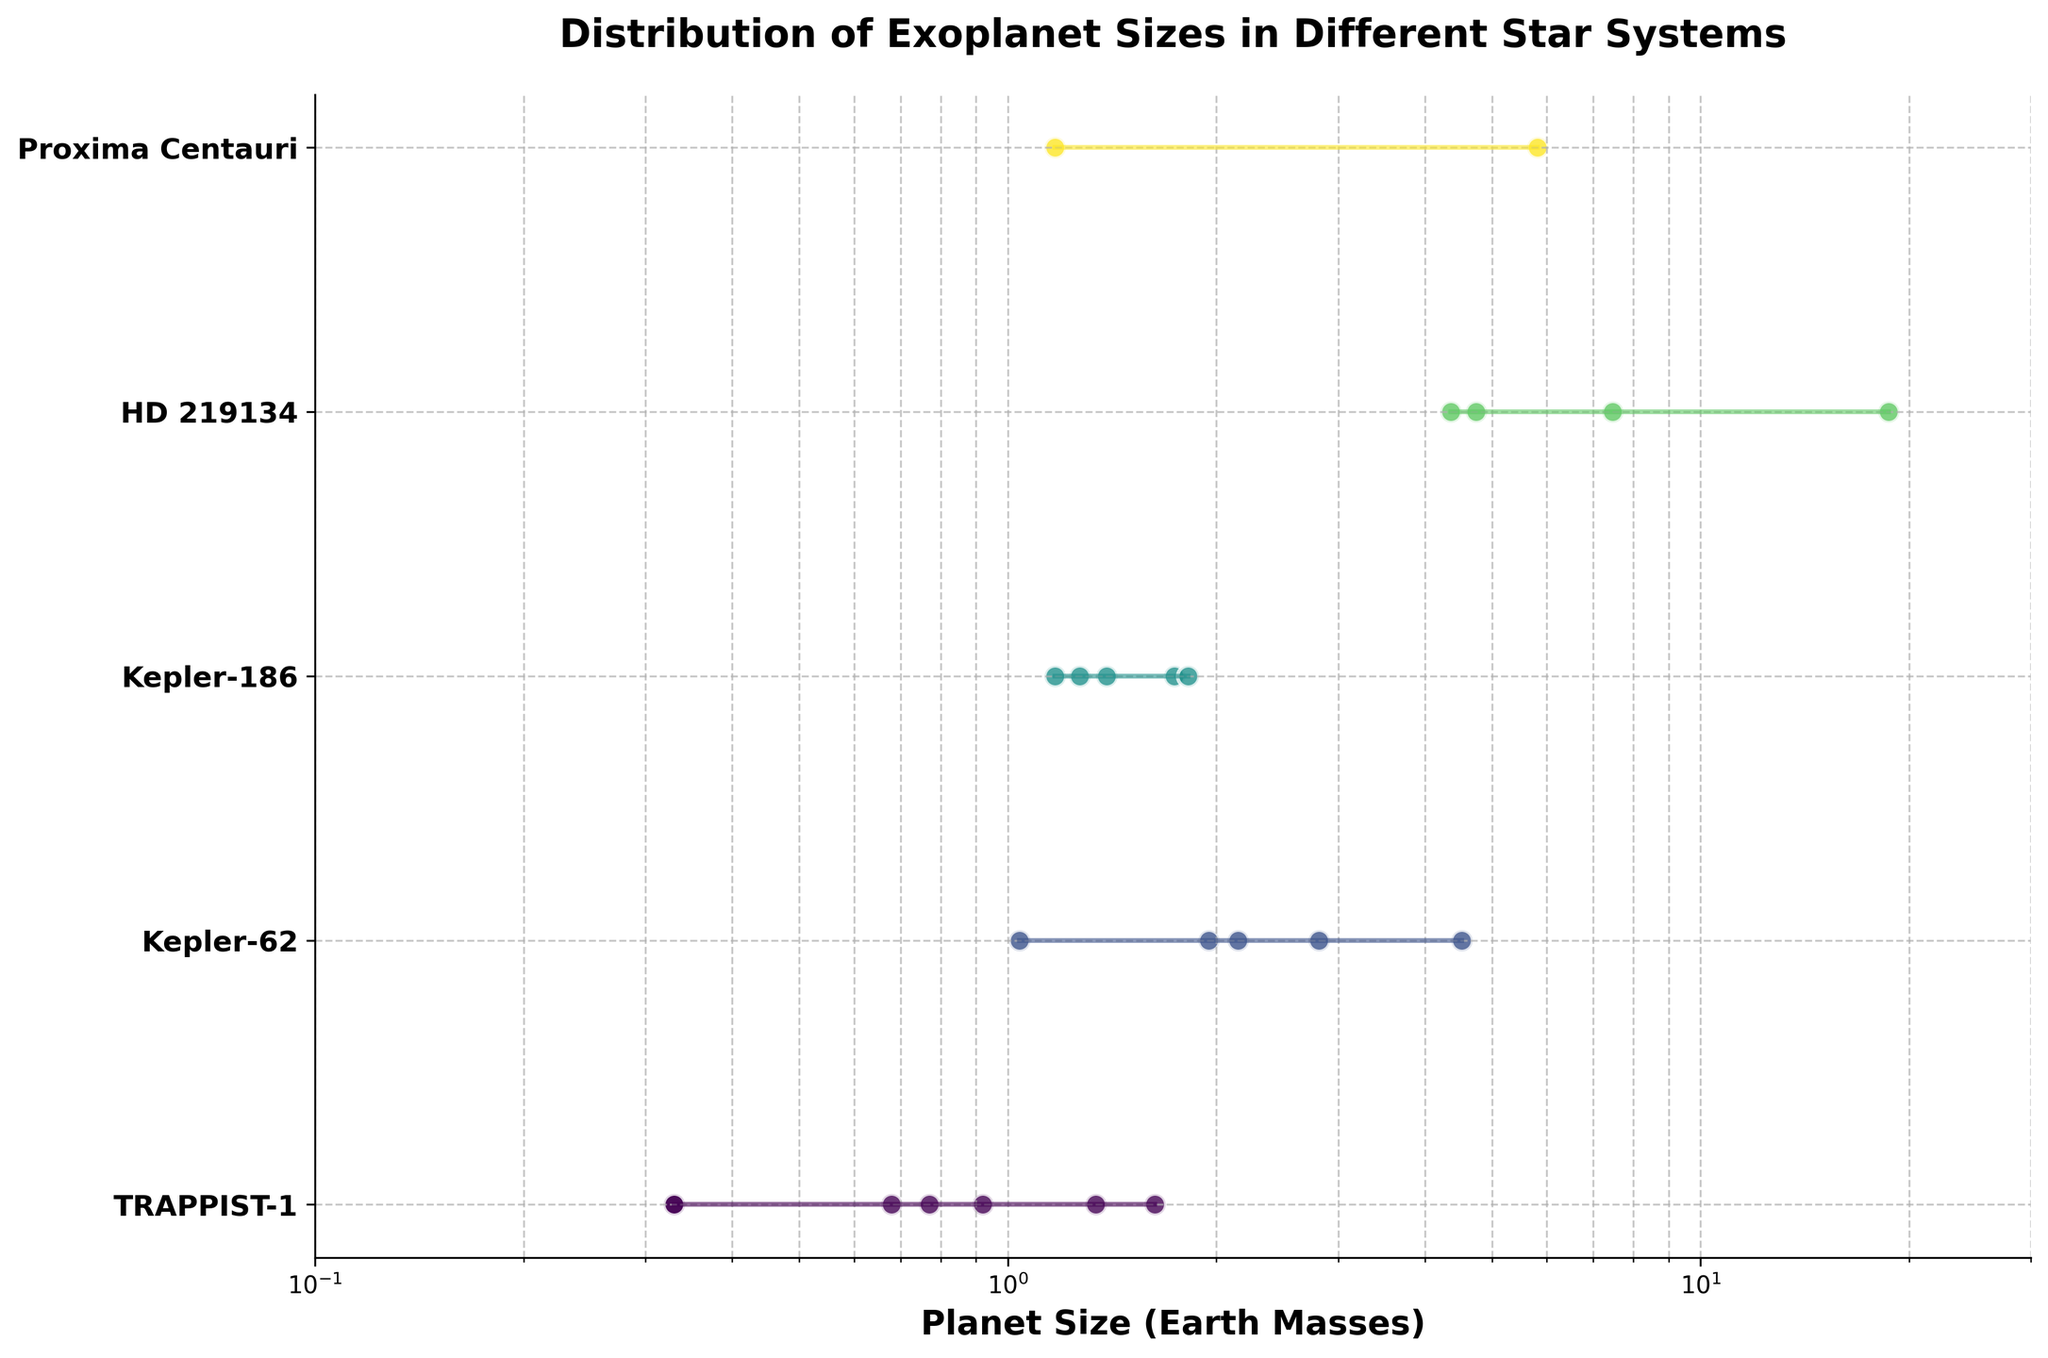What is the title of the plot? The title of the plot is displayed at the top and reads "Distribution of Exoplanet Sizes in Different Star Systems."
Answer: Distribution of Exoplanet Sizes in Different Star Systems How many star systems are represented in the plot? By counting the number of unique star systems listed along the y-axis, we can see there are 5 star systems.
Answer: 5 Which star system has the smallest range of planet sizes? By looking at the lines representing the ranges of planet sizes, the TRAPPIST-1 system has the shortest line, indicating the smallest range.
Answer: TRAPPIST-1 Which star system has the largest planet by size, and what is the size? By identifying the longest dot furthest to the right on the x-axis, HD 219134g in the HD 219134 system is the largest, with a size of 18.69 Earth masses.
Answer: HD 219134, 18.69 Earth masses Which star system has the smallest planet by size, and what is the size? By identifying the smallest dot furthest to the left on the x-axis, TRAPPIST-1d and TRAPPIST-1h are the smallest, both with a size of 0.33 Earth masses.
Answer: TRAPPIST-1, 0.33 Earth masses What is the average size of planets in the Kepler-62 system? The sizes of the planets in Kepler-62 are 1.95, 1.04, 2.15, 4.52, and 2.81. Adding these values gives 12.47. Dividing by the number of planets (5), the average size is 12.47/5 = 2.494 Earth masses.
Answer: 2.494 Earth masses Which star system has the widest range of planet sizes? By examining the lengths of the lines, HD 219134 has the longest line, suggesting the widest range of planet sizes from 4.74 to 18.69 Earth masses.
Answer: HD 219134 Between Kepler-186 and Proxima Centauri, which star system has a larger maximum planet size? By comparing the rightmost dots, Kepler-186f (1.82 Earth masses) and Proxima Centauri c (5.81 Earth masses), Proxima Centauri has a larger maximum planet size.
Answer: Proxima Centauri What is the median size of the planets in the TRAPPIST-1 system? The planet sizes in TRAPPIST-1 are 0.33, 0.33, 0.68, 0.77, 0.92, 1.34, 1.63. The median is the middle value when the sizes are sorted in order, which is 0.92 Earth masses.
Answer: 0.92 Earth masses Are there any star systems where all planets are roughly the same size? By looking for lines that are very short, indicating small variance, none of the represented star systems have all planets of roughly the same size; however, TRAPPIST-1's planets' sizes are relatively closer compared to other systems.
Answer: No, but TRAPPIST-1 is relatively closer 